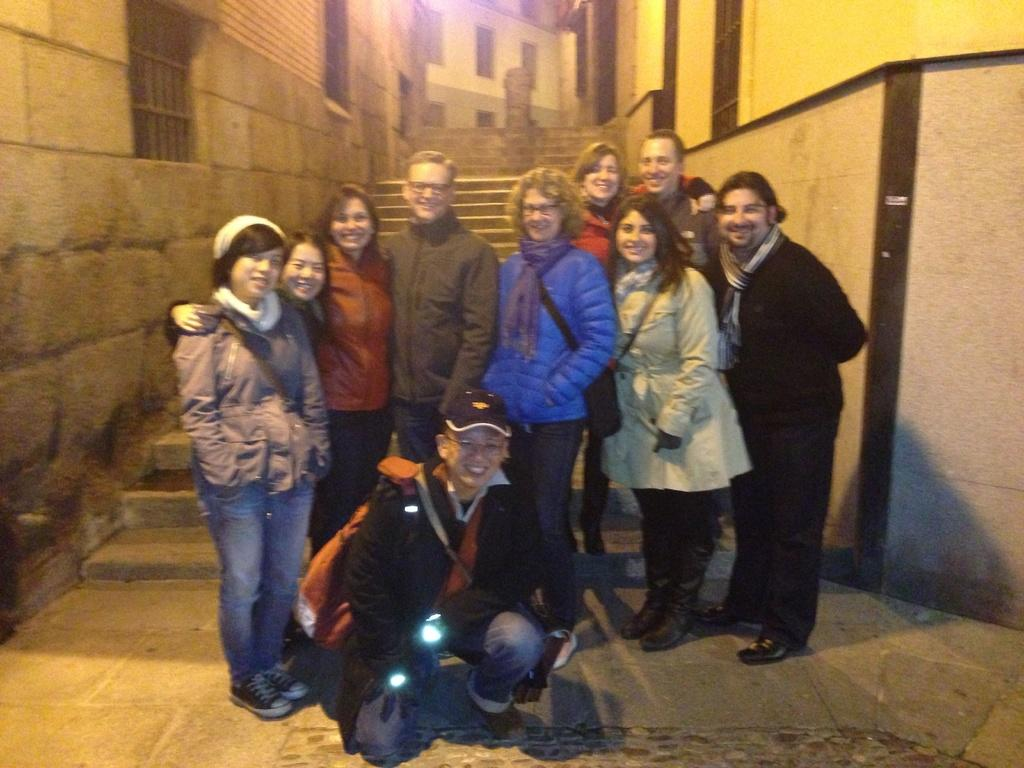What are the people in the image doing? The people in the image are standing in the center. What is the position of the boy in the image? The boy is sitting at the bottom of the image. What can be seen illuminated in the image? Lights are visible in the image. What architectural feature is present in the background of the image? There are stairs in the background of the image. What type of structures can be seen in the distance? There are buildings in the background of the image. Can you hear the boy crying in the image? There is no sound in the image, so it is not possible to determine if the boy is crying or not. 